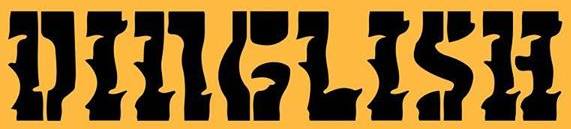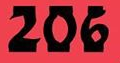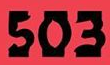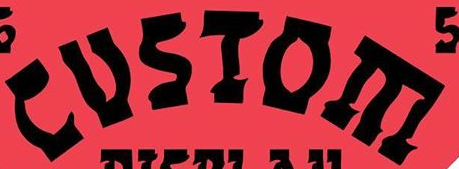Read the text from these images in sequence, separated by a semicolon. DINGLISH; 206; 503; CUSIOE 